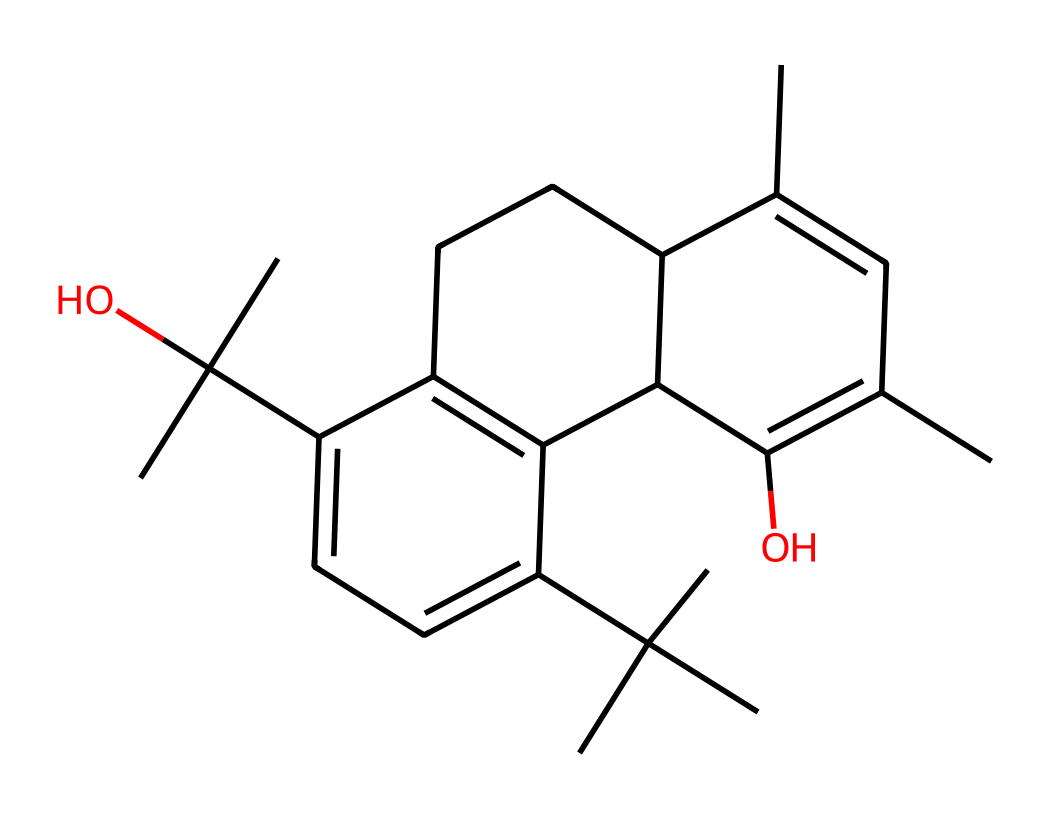What is the name of this compound? The chemical structure represented by the provided SMILES is tetrahydrocannabinol. This can be determined by analyzing the SMILES notation, which contains the distinct characteristics and rings typical of THC.
Answer: tetrahydrocannabinol How many carbon atoms are in the structure? By examining the SMILES, we can count all the 'C' atoms present. In this case, there are 21 carbon atoms in total, which are explicitly represented in the SMILES string.
Answer: 21 How many hydroxyl (-OH) groups are present? The SMILES contains one instance of 'O' that is not connected to another carbon atom, indicating that it is part of a hydroxyl group. Therefore, there is one hydroxyl group present in the structure.
Answer: 1 Does the compound contain a double bond? In the SMILES notation, there are parts represented with '=', indicating double bonds. A close examination of the structure shows multiple segments where these double bonds occur, confirming its presence.
Answer: Yes What is the primary functional group in THC? By analyzing the structure, the primary functional group in this compound is the hydroxyl group, which is clearly seen as a -OH group attached to the carbon atoms. This group is responsible for many properties of THC.
Answer: Hydroxyl group Is this compound saturated or unsaturated? This compound contains double bonds, as identified from the '=' signs in the structure. The presence of such bonds indicates that the compound is unsaturated, as it does not have the maximum number of hydrogen atoms possible.
Answer: Unsaturated 